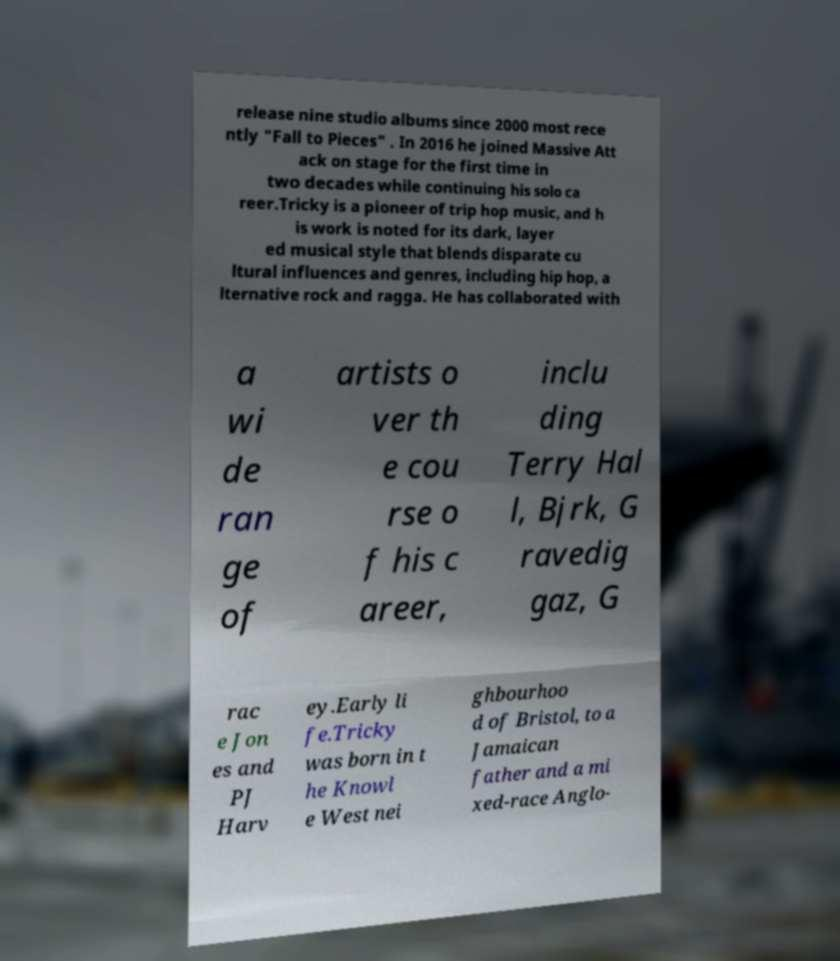For documentation purposes, I need the text within this image transcribed. Could you provide that? release nine studio albums since 2000 most rece ntly "Fall to Pieces" . In 2016 he joined Massive Att ack on stage for the first time in two decades while continuing his solo ca reer.Tricky is a pioneer of trip hop music, and h is work is noted for its dark, layer ed musical style that blends disparate cu ltural influences and genres, including hip hop, a lternative rock and ragga. He has collaborated with a wi de ran ge of artists o ver th e cou rse o f his c areer, inclu ding Terry Hal l, Bjrk, G ravedig gaz, G rac e Jon es and PJ Harv ey.Early li fe.Tricky was born in t he Knowl e West nei ghbourhoo d of Bristol, to a Jamaican father and a mi xed-race Anglo- 